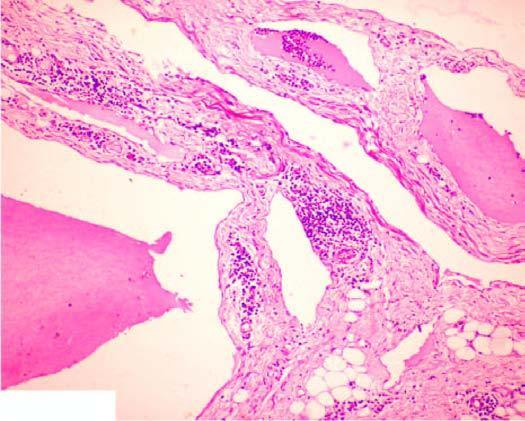what are present?
Answer the question using a single word or phrase. Large cystic spaces 